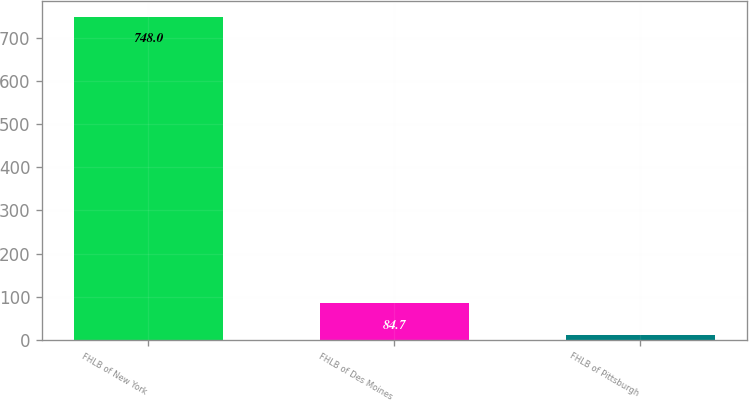Convert chart. <chart><loc_0><loc_0><loc_500><loc_500><bar_chart><fcel>FHLB of New York<fcel>FHLB of Des Moines<fcel>FHLB of Pittsburgh<nl><fcel>748<fcel>84.7<fcel>11<nl></chart> 